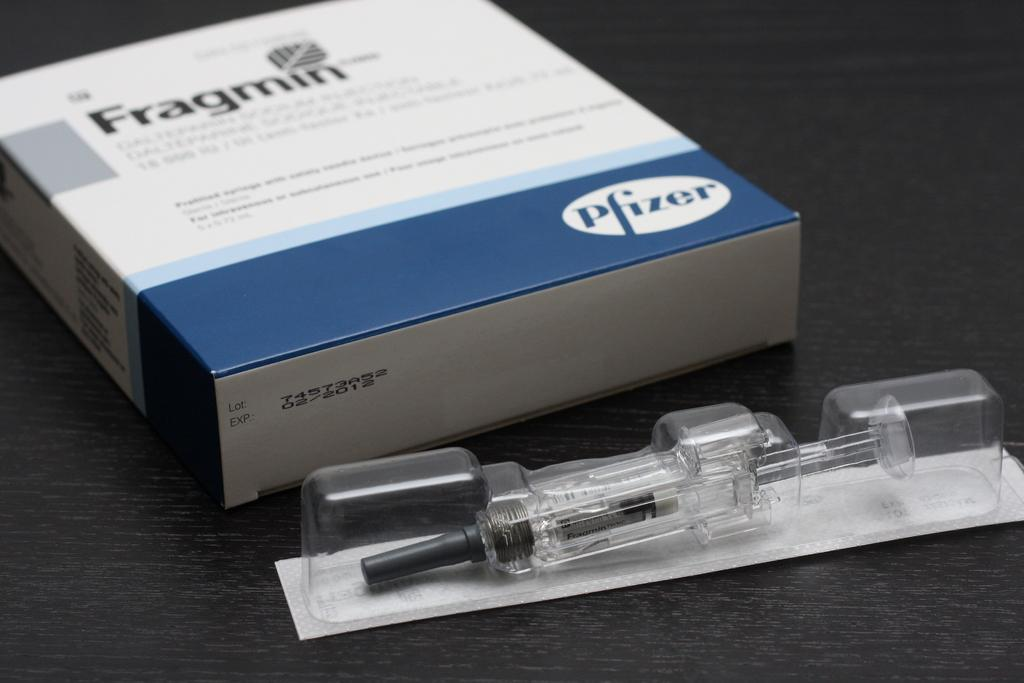<image>
Offer a succinct explanation of the picture presented. A Fragmin box with the label Pfizer on the bottom and a plastic container 